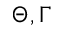Convert formula to latex. <formula><loc_0><loc_0><loc_500><loc_500>\Theta , \Gamma</formula> 